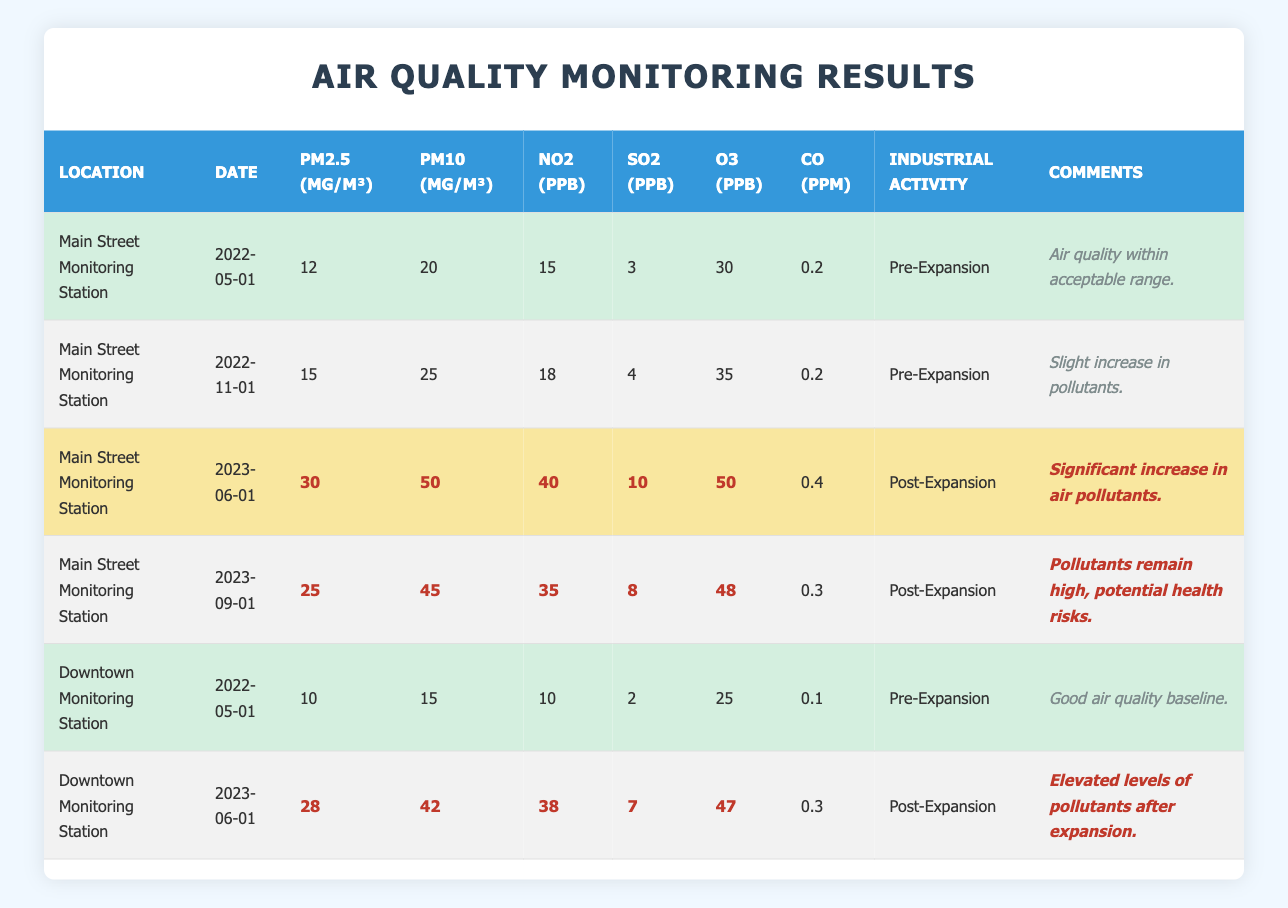What was the PM2.5 level on Main Street before the industrial expansion? Referring to the rows related to Main Street under "Pre-Expansion", on 2022-05-01, the PM2.5 level was recorded at 12 µg/m³.
Answer: 12 µg/m³ How much did the NO2 level increase from Pre-Expansion to Post-Expansion at Main Street? For Main Street, the NO2 level was 18 ppb prior to expansion (on 2022-11-01) and increased to 40 ppb after expansion (on 2023-06-01). The increase is 40 - 18 = 22 ppb.
Answer: 22 ppb Is it true that Downtown had better air quality than Main Street before the industrial expansion? Before expansion, Downtown recorded PM2.5 at 10 µg/m³, PM10 at 15 µg/m³, and NO2 at 10 ppb, while Main Street had PM2.5 at 12 µg/m³, PM10 at 20 µg/m³, and NO2 at 15 ppb. Therefore, Downtown had lower levels in each category.
Answer: Yes What is the date when pollutants were significantly high at Main Street after the expansion? In the Post-Expansion phase, the significant increase was recorded on 2023-06-01 when pollutants exceeded previous levels. This date has comments indicating significant increase.
Answer: 2023-06-01 What was the average PM10 level at both monitoring stations before and after the industrial expansion? Pre-Expansion PM10 values: Main Street = 20 µg/m³ and Downtown = 15 µg/m³, so average = (20 + 15) / 2 = 17.5 µg/m³. Post-Expansion PM10 values: Main Street = 50 µg/m³ and Downtown = 42 µg/m³, so average = (50 + 42) / 2 = 46 µg/m³.
Answer: Pre: 17.5 µg/m³, Post: 46 µg/m³ What was the highest SO2 level recorded at any of the monitoring stations? Looking at the table, Main Street had the highest SO2 level post-expansion, recorded at 10 ppb on 2023-06-01.
Answer: 10 ppb 